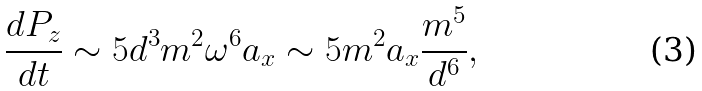Convert formula to latex. <formula><loc_0><loc_0><loc_500><loc_500>\frac { d P _ { z } } { d t } \sim 5 d ^ { 3 } m ^ { 2 } \omega ^ { 6 } a _ { x } \sim 5 m ^ { 2 } a _ { x } \frac { m ^ { 5 } } { d ^ { 6 } } ,</formula> 